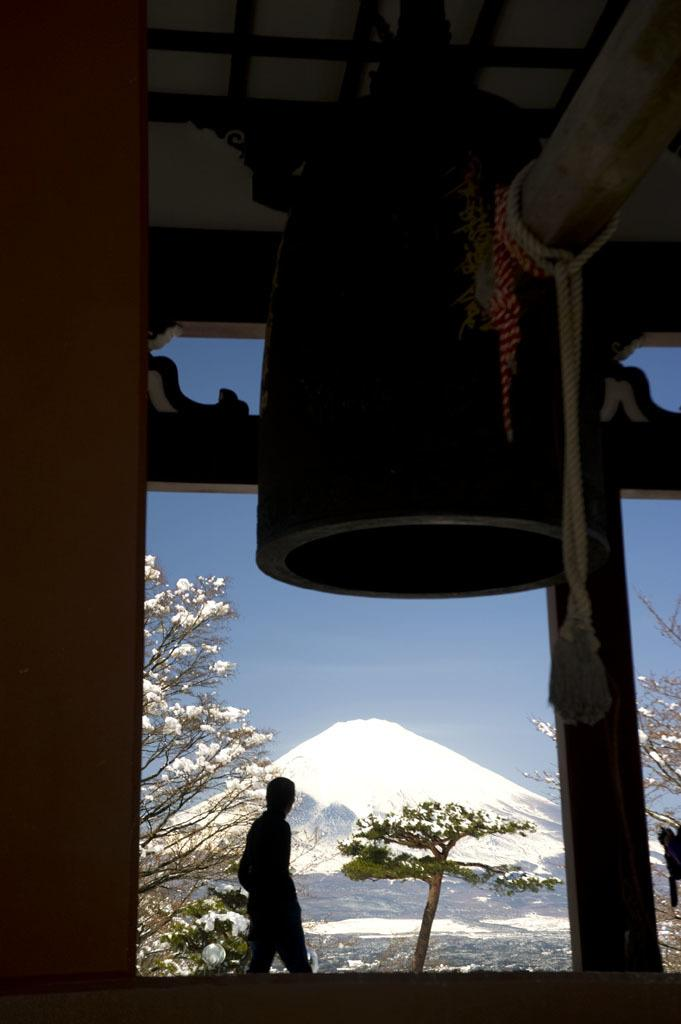Who or what is the main subject in the image? There is a person in the image. What can be seen in the background of the image? There are trees covered with snow and mountains visible in the background. What is the color of the sky in the image? The sky is blue in color. How many cherries are on the person's head in the image? There are no cherries present on the person's head in the image. What question is the person asking in the image? The image does not show the person asking a question, so we cannot determine what question they might be asking. 